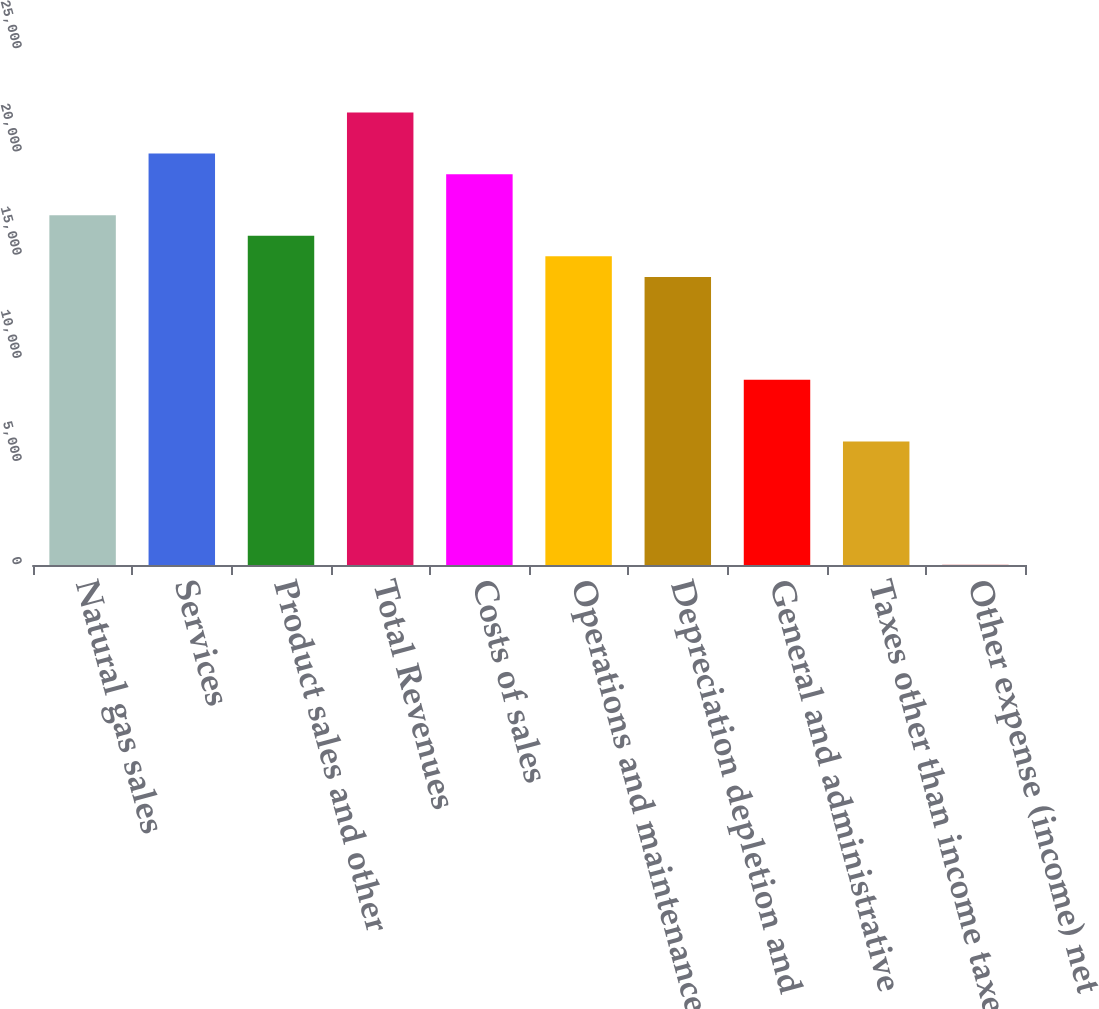<chart> <loc_0><loc_0><loc_500><loc_500><bar_chart><fcel>Natural gas sales<fcel>Services<fcel>Product sales and other<fcel>Total Revenues<fcel>Costs of sales<fcel>Operations and maintenance<fcel>Depreciation depletion and<fcel>General and administrative<fcel>Taxes other than income taxes<fcel>Other expense (income) net<nl><fcel>16945<fcel>19933<fcel>15949<fcel>21925<fcel>18937<fcel>14953<fcel>13957<fcel>8977<fcel>5989<fcel>13<nl></chart> 